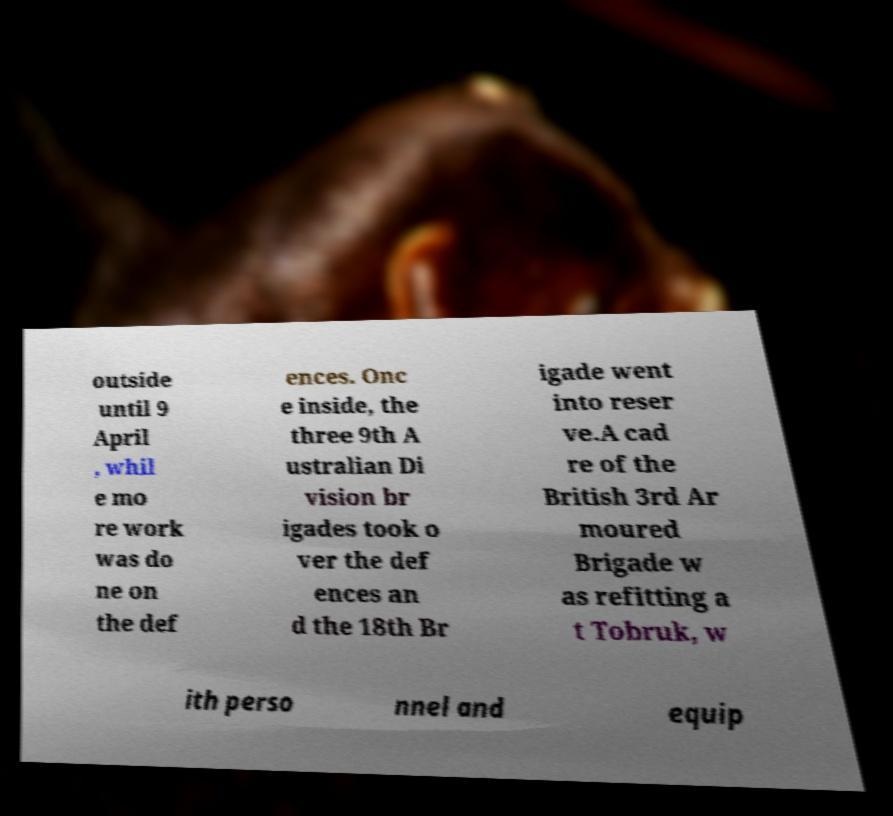There's text embedded in this image that I need extracted. Can you transcribe it verbatim? outside until 9 April , whil e mo re work was do ne on the def ences. Onc e inside, the three 9th A ustralian Di vision br igades took o ver the def ences an d the 18th Br igade went into reser ve.A cad re of the British 3rd Ar moured Brigade w as refitting a t Tobruk, w ith perso nnel and equip 